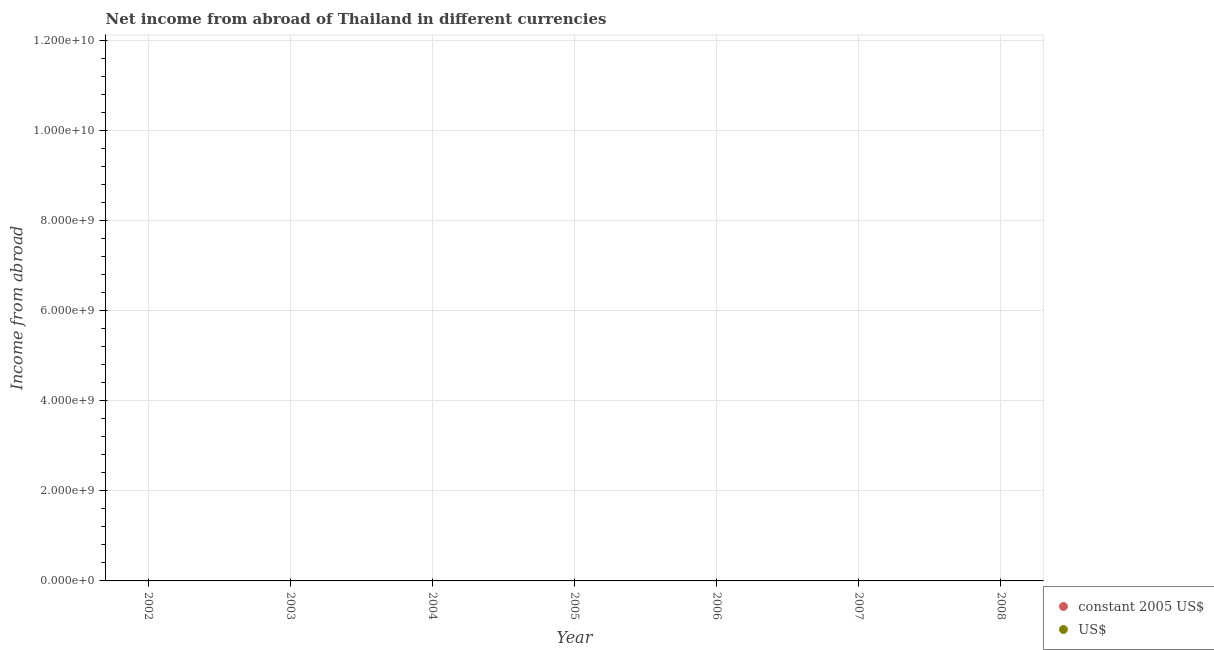What is the total income from abroad in us$ in the graph?
Offer a terse response. 0. What is the difference between the income from abroad in constant 2005 us$ in 2007 and the income from abroad in us$ in 2008?
Make the answer very short. 0. What is the average income from abroad in constant 2005 us$ per year?
Your response must be concise. 0. In how many years, is the income from abroad in constant 2005 us$ greater than the average income from abroad in constant 2005 us$ taken over all years?
Offer a very short reply. 0. Does the income from abroad in us$ monotonically increase over the years?
Provide a succinct answer. No. How many dotlines are there?
Give a very brief answer. 0. What is the difference between two consecutive major ticks on the Y-axis?
Provide a short and direct response. 2.00e+09. Does the graph contain any zero values?
Offer a very short reply. Yes. Does the graph contain grids?
Your answer should be compact. Yes. Where does the legend appear in the graph?
Your answer should be very brief. Bottom right. How are the legend labels stacked?
Offer a very short reply. Vertical. What is the title of the graph?
Provide a short and direct response. Net income from abroad of Thailand in different currencies. Does "Sanitation services" appear as one of the legend labels in the graph?
Your answer should be compact. No. What is the label or title of the Y-axis?
Ensure brevity in your answer.  Income from abroad. What is the Income from abroad in US$ in 2003?
Your answer should be compact. 0. What is the Income from abroad in US$ in 2004?
Provide a succinct answer. 0. What is the Income from abroad of US$ in 2006?
Offer a terse response. 0. What is the Income from abroad in constant 2005 US$ in 2007?
Your response must be concise. 0. What is the Income from abroad in constant 2005 US$ in 2008?
Ensure brevity in your answer.  0. What is the Income from abroad in US$ in 2008?
Your response must be concise. 0. What is the total Income from abroad in constant 2005 US$ in the graph?
Provide a short and direct response. 0. What is the total Income from abroad in US$ in the graph?
Ensure brevity in your answer.  0. What is the average Income from abroad of constant 2005 US$ per year?
Give a very brief answer. 0. 